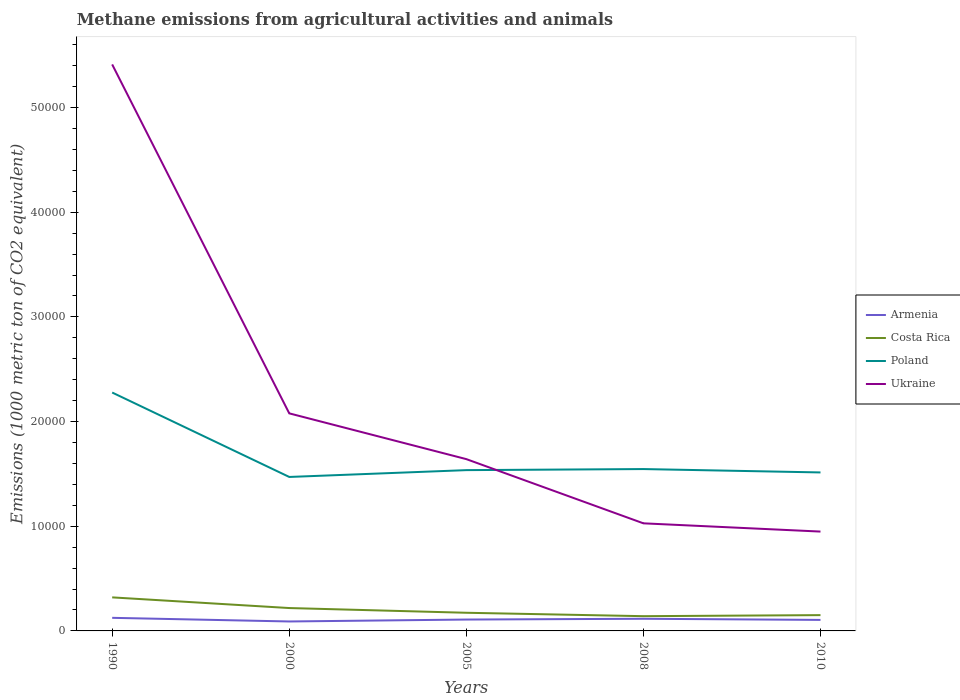Does the line corresponding to Ukraine intersect with the line corresponding to Armenia?
Offer a terse response. No. Across all years, what is the maximum amount of methane emitted in Costa Rica?
Provide a short and direct response. 1409.6. In which year was the amount of methane emitted in Armenia maximum?
Keep it short and to the point. 2000. What is the total amount of methane emitted in Ukraine in the graph?
Your response must be concise. 4.38e+04. What is the difference between the highest and the second highest amount of methane emitted in Costa Rica?
Make the answer very short. 1795. What is the difference between the highest and the lowest amount of methane emitted in Ukraine?
Offer a terse response. 1. How many lines are there?
Provide a short and direct response. 4. What is the difference between two consecutive major ticks on the Y-axis?
Offer a very short reply. 10000. Does the graph contain any zero values?
Give a very brief answer. No. Does the graph contain grids?
Provide a short and direct response. No. Where does the legend appear in the graph?
Ensure brevity in your answer.  Center right. How many legend labels are there?
Make the answer very short. 4. What is the title of the graph?
Give a very brief answer. Methane emissions from agricultural activities and animals. What is the label or title of the X-axis?
Your answer should be compact. Years. What is the label or title of the Y-axis?
Offer a very short reply. Emissions (1000 metric ton of CO2 equivalent). What is the Emissions (1000 metric ton of CO2 equivalent) in Armenia in 1990?
Provide a succinct answer. 1250.4. What is the Emissions (1000 metric ton of CO2 equivalent) of Costa Rica in 1990?
Your answer should be compact. 3204.6. What is the Emissions (1000 metric ton of CO2 equivalent) of Poland in 1990?
Offer a terse response. 2.28e+04. What is the Emissions (1000 metric ton of CO2 equivalent) in Ukraine in 1990?
Provide a short and direct response. 5.41e+04. What is the Emissions (1000 metric ton of CO2 equivalent) in Armenia in 2000?
Your response must be concise. 903.1. What is the Emissions (1000 metric ton of CO2 equivalent) in Costa Rica in 2000?
Offer a very short reply. 2184.6. What is the Emissions (1000 metric ton of CO2 equivalent) of Poland in 2000?
Ensure brevity in your answer.  1.47e+04. What is the Emissions (1000 metric ton of CO2 equivalent) in Ukraine in 2000?
Provide a succinct answer. 2.08e+04. What is the Emissions (1000 metric ton of CO2 equivalent) in Armenia in 2005?
Your answer should be very brief. 1086. What is the Emissions (1000 metric ton of CO2 equivalent) in Costa Rica in 2005?
Provide a short and direct response. 1735. What is the Emissions (1000 metric ton of CO2 equivalent) of Poland in 2005?
Give a very brief answer. 1.54e+04. What is the Emissions (1000 metric ton of CO2 equivalent) of Ukraine in 2005?
Offer a very short reply. 1.64e+04. What is the Emissions (1000 metric ton of CO2 equivalent) in Armenia in 2008?
Your answer should be very brief. 1161.5. What is the Emissions (1000 metric ton of CO2 equivalent) in Costa Rica in 2008?
Ensure brevity in your answer.  1409.6. What is the Emissions (1000 metric ton of CO2 equivalent) in Poland in 2008?
Keep it short and to the point. 1.55e+04. What is the Emissions (1000 metric ton of CO2 equivalent) in Ukraine in 2008?
Give a very brief answer. 1.03e+04. What is the Emissions (1000 metric ton of CO2 equivalent) of Armenia in 2010?
Your answer should be very brief. 1051.7. What is the Emissions (1000 metric ton of CO2 equivalent) in Costa Rica in 2010?
Provide a short and direct response. 1509.2. What is the Emissions (1000 metric ton of CO2 equivalent) in Poland in 2010?
Ensure brevity in your answer.  1.51e+04. What is the Emissions (1000 metric ton of CO2 equivalent) in Ukraine in 2010?
Offer a terse response. 9489.8. Across all years, what is the maximum Emissions (1000 metric ton of CO2 equivalent) in Armenia?
Ensure brevity in your answer.  1250.4. Across all years, what is the maximum Emissions (1000 metric ton of CO2 equivalent) in Costa Rica?
Your answer should be very brief. 3204.6. Across all years, what is the maximum Emissions (1000 metric ton of CO2 equivalent) of Poland?
Provide a succinct answer. 2.28e+04. Across all years, what is the maximum Emissions (1000 metric ton of CO2 equivalent) of Ukraine?
Make the answer very short. 5.41e+04. Across all years, what is the minimum Emissions (1000 metric ton of CO2 equivalent) of Armenia?
Make the answer very short. 903.1. Across all years, what is the minimum Emissions (1000 metric ton of CO2 equivalent) of Costa Rica?
Give a very brief answer. 1409.6. Across all years, what is the minimum Emissions (1000 metric ton of CO2 equivalent) in Poland?
Make the answer very short. 1.47e+04. Across all years, what is the minimum Emissions (1000 metric ton of CO2 equivalent) of Ukraine?
Your answer should be very brief. 9489.8. What is the total Emissions (1000 metric ton of CO2 equivalent) in Armenia in the graph?
Make the answer very short. 5452.7. What is the total Emissions (1000 metric ton of CO2 equivalent) of Costa Rica in the graph?
Offer a very short reply. 1.00e+04. What is the total Emissions (1000 metric ton of CO2 equivalent) in Poland in the graph?
Make the answer very short. 8.34e+04. What is the total Emissions (1000 metric ton of CO2 equivalent) in Ukraine in the graph?
Your answer should be very brief. 1.11e+05. What is the difference between the Emissions (1000 metric ton of CO2 equivalent) in Armenia in 1990 and that in 2000?
Your response must be concise. 347.3. What is the difference between the Emissions (1000 metric ton of CO2 equivalent) of Costa Rica in 1990 and that in 2000?
Your answer should be compact. 1020. What is the difference between the Emissions (1000 metric ton of CO2 equivalent) of Poland in 1990 and that in 2000?
Offer a very short reply. 8065. What is the difference between the Emissions (1000 metric ton of CO2 equivalent) in Ukraine in 1990 and that in 2000?
Provide a short and direct response. 3.33e+04. What is the difference between the Emissions (1000 metric ton of CO2 equivalent) in Armenia in 1990 and that in 2005?
Keep it short and to the point. 164.4. What is the difference between the Emissions (1000 metric ton of CO2 equivalent) in Costa Rica in 1990 and that in 2005?
Keep it short and to the point. 1469.6. What is the difference between the Emissions (1000 metric ton of CO2 equivalent) of Poland in 1990 and that in 2005?
Provide a short and direct response. 7413.7. What is the difference between the Emissions (1000 metric ton of CO2 equivalent) of Ukraine in 1990 and that in 2005?
Your answer should be very brief. 3.77e+04. What is the difference between the Emissions (1000 metric ton of CO2 equivalent) in Armenia in 1990 and that in 2008?
Keep it short and to the point. 88.9. What is the difference between the Emissions (1000 metric ton of CO2 equivalent) of Costa Rica in 1990 and that in 2008?
Provide a short and direct response. 1795. What is the difference between the Emissions (1000 metric ton of CO2 equivalent) of Poland in 1990 and that in 2008?
Provide a succinct answer. 7311.1. What is the difference between the Emissions (1000 metric ton of CO2 equivalent) in Ukraine in 1990 and that in 2008?
Ensure brevity in your answer.  4.38e+04. What is the difference between the Emissions (1000 metric ton of CO2 equivalent) in Armenia in 1990 and that in 2010?
Provide a succinct answer. 198.7. What is the difference between the Emissions (1000 metric ton of CO2 equivalent) in Costa Rica in 1990 and that in 2010?
Provide a short and direct response. 1695.4. What is the difference between the Emissions (1000 metric ton of CO2 equivalent) of Poland in 1990 and that in 2010?
Your answer should be very brief. 7634.1. What is the difference between the Emissions (1000 metric ton of CO2 equivalent) of Ukraine in 1990 and that in 2010?
Ensure brevity in your answer.  4.46e+04. What is the difference between the Emissions (1000 metric ton of CO2 equivalent) in Armenia in 2000 and that in 2005?
Make the answer very short. -182.9. What is the difference between the Emissions (1000 metric ton of CO2 equivalent) in Costa Rica in 2000 and that in 2005?
Your answer should be compact. 449.6. What is the difference between the Emissions (1000 metric ton of CO2 equivalent) in Poland in 2000 and that in 2005?
Your response must be concise. -651.3. What is the difference between the Emissions (1000 metric ton of CO2 equivalent) in Ukraine in 2000 and that in 2005?
Make the answer very short. 4372.1. What is the difference between the Emissions (1000 metric ton of CO2 equivalent) of Armenia in 2000 and that in 2008?
Offer a terse response. -258.4. What is the difference between the Emissions (1000 metric ton of CO2 equivalent) of Costa Rica in 2000 and that in 2008?
Keep it short and to the point. 775. What is the difference between the Emissions (1000 metric ton of CO2 equivalent) in Poland in 2000 and that in 2008?
Offer a very short reply. -753.9. What is the difference between the Emissions (1000 metric ton of CO2 equivalent) of Ukraine in 2000 and that in 2008?
Give a very brief answer. 1.05e+04. What is the difference between the Emissions (1000 metric ton of CO2 equivalent) of Armenia in 2000 and that in 2010?
Make the answer very short. -148.6. What is the difference between the Emissions (1000 metric ton of CO2 equivalent) of Costa Rica in 2000 and that in 2010?
Keep it short and to the point. 675.4. What is the difference between the Emissions (1000 metric ton of CO2 equivalent) in Poland in 2000 and that in 2010?
Offer a very short reply. -430.9. What is the difference between the Emissions (1000 metric ton of CO2 equivalent) in Ukraine in 2000 and that in 2010?
Give a very brief answer. 1.13e+04. What is the difference between the Emissions (1000 metric ton of CO2 equivalent) of Armenia in 2005 and that in 2008?
Your response must be concise. -75.5. What is the difference between the Emissions (1000 metric ton of CO2 equivalent) of Costa Rica in 2005 and that in 2008?
Make the answer very short. 325.4. What is the difference between the Emissions (1000 metric ton of CO2 equivalent) in Poland in 2005 and that in 2008?
Your response must be concise. -102.6. What is the difference between the Emissions (1000 metric ton of CO2 equivalent) in Ukraine in 2005 and that in 2008?
Keep it short and to the point. 6133.4. What is the difference between the Emissions (1000 metric ton of CO2 equivalent) of Armenia in 2005 and that in 2010?
Your answer should be very brief. 34.3. What is the difference between the Emissions (1000 metric ton of CO2 equivalent) of Costa Rica in 2005 and that in 2010?
Give a very brief answer. 225.8. What is the difference between the Emissions (1000 metric ton of CO2 equivalent) in Poland in 2005 and that in 2010?
Your response must be concise. 220.4. What is the difference between the Emissions (1000 metric ton of CO2 equivalent) in Ukraine in 2005 and that in 2010?
Ensure brevity in your answer.  6921.6. What is the difference between the Emissions (1000 metric ton of CO2 equivalent) in Armenia in 2008 and that in 2010?
Give a very brief answer. 109.8. What is the difference between the Emissions (1000 metric ton of CO2 equivalent) of Costa Rica in 2008 and that in 2010?
Your response must be concise. -99.6. What is the difference between the Emissions (1000 metric ton of CO2 equivalent) of Poland in 2008 and that in 2010?
Provide a short and direct response. 323. What is the difference between the Emissions (1000 metric ton of CO2 equivalent) of Ukraine in 2008 and that in 2010?
Offer a very short reply. 788.2. What is the difference between the Emissions (1000 metric ton of CO2 equivalent) in Armenia in 1990 and the Emissions (1000 metric ton of CO2 equivalent) in Costa Rica in 2000?
Offer a terse response. -934.2. What is the difference between the Emissions (1000 metric ton of CO2 equivalent) in Armenia in 1990 and the Emissions (1000 metric ton of CO2 equivalent) in Poland in 2000?
Offer a very short reply. -1.35e+04. What is the difference between the Emissions (1000 metric ton of CO2 equivalent) of Armenia in 1990 and the Emissions (1000 metric ton of CO2 equivalent) of Ukraine in 2000?
Make the answer very short. -1.95e+04. What is the difference between the Emissions (1000 metric ton of CO2 equivalent) of Costa Rica in 1990 and the Emissions (1000 metric ton of CO2 equivalent) of Poland in 2000?
Make the answer very short. -1.15e+04. What is the difference between the Emissions (1000 metric ton of CO2 equivalent) in Costa Rica in 1990 and the Emissions (1000 metric ton of CO2 equivalent) in Ukraine in 2000?
Keep it short and to the point. -1.76e+04. What is the difference between the Emissions (1000 metric ton of CO2 equivalent) of Poland in 1990 and the Emissions (1000 metric ton of CO2 equivalent) of Ukraine in 2000?
Your answer should be compact. 1990. What is the difference between the Emissions (1000 metric ton of CO2 equivalent) of Armenia in 1990 and the Emissions (1000 metric ton of CO2 equivalent) of Costa Rica in 2005?
Provide a short and direct response. -484.6. What is the difference between the Emissions (1000 metric ton of CO2 equivalent) in Armenia in 1990 and the Emissions (1000 metric ton of CO2 equivalent) in Poland in 2005?
Your response must be concise. -1.41e+04. What is the difference between the Emissions (1000 metric ton of CO2 equivalent) of Armenia in 1990 and the Emissions (1000 metric ton of CO2 equivalent) of Ukraine in 2005?
Provide a short and direct response. -1.52e+04. What is the difference between the Emissions (1000 metric ton of CO2 equivalent) in Costa Rica in 1990 and the Emissions (1000 metric ton of CO2 equivalent) in Poland in 2005?
Provide a short and direct response. -1.22e+04. What is the difference between the Emissions (1000 metric ton of CO2 equivalent) of Costa Rica in 1990 and the Emissions (1000 metric ton of CO2 equivalent) of Ukraine in 2005?
Your answer should be very brief. -1.32e+04. What is the difference between the Emissions (1000 metric ton of CO2 equivalent) of Poland in 1990 and the Emissions (1000 metric ton of CO2 equivalent) of Ukraine in 2005?
Give a very brief answer. 6362.1. What is the difference between the Emissions (1000 metric ton of CO2 equivalent) of Armenia in 1990 and the Emissions (1000 metric ton of CO2 equivalent) of Costa Rica in 2008?
Your answer should be very brief. -159.2. What is the difference between the Emissions (1000 metric ton of CO2 equivalent) in Armenia in 1990 and the Emissions (1000 metric ton of CO2 equivalent) in Poland in 2008?
Provide a succinct answer. -1.42e+04. What is the difference between the Emissions (1000 metric ton of CO2 equivalent) of Armenia in 1990 and the Emissions (1000 metric ton of CO2 equivalent) of Ukraine in 2008?
Your answer should be compact. -9027.6. What is the difference between the Emissions (1000 metric ton of CO2 equivalent) of Costa Rica in 1990 and the Emissions (1000 metric ton of CO2 equivalent) of Poland in 2008?
Offer a terse response. -1.23e+04. What is the difference between the Emissions (1000 metric ton of CO2 equivalent) of Costa Rica in 1990 and the Emissions (1000 metric ton of CO2 equivalent) of Ukraine in 2008?
Your answer should be very brief. -7073.4. What is the difference between the Emissions (1000 metric ton of CO2 equivalent) of Poland in 1990 and the Emissions (1000 metric ton of CO2 equivalent) of Ukraine in 2008?
Provide a short and direct response. 1.25e+04. What is the difference between the Emissions (1000 metric ton of CO2 equivalent) in Armenia in 1990 and the Emissions (1000 metric ton of CO2 equivalent) in Costa Rica in 2010?
Make the answer very short. -258.8. What is the difference between the Emissions (1000 metric ton of CO2 equivalent) in Armenia in 1990 and the Emissions (1000 metric ton of CO2 equivalent) in Poland in 2010?
Give a very brief answer. -1.39e+04. What is the difference between the Emissions (1000 metric ton of CO2 equivalent) of Armenia in 1990 and the Emissions (1000 metric ton of CO2 equivalent) of Ukraine in 2010?
Your response must be concise. -8239.4. What is the difference between the Emissions (1000 metric ton of CO2 equivalent) in Costa Rica in 1990 and the Emissions (1000 metric ton of CO2 equivalent) in Poland in 2010?
Your response must be concise. -1.19e+04. What is the difference between the Emissions (1000 metric ton of CO2 equivalent) of Costa Rica in 1990 and the Emissions (1000 metric ton of CO2 equivalent) of Ukraine in 2010?
Give a very brief answer. -6285.2. What is the difference between the Emissions (1000 metric ton of CO2 equivalent) in Poland in 1990 and the Emissions (1000 metric ton of CO2 equivalent) in Ukraine in 2010?
Ensure brevity in your answer.  1.33e+04. What is the difference between the Emissions (1000 metric ton of CO2 equivalent) of Armenia in 2000 and the Emissions (1000 metric ton of CO2 equivalent) of Costa Rica in 2005?
Offer a terse response. -831.9. What is the difference between the Emissions (1000 metric ton of CO2 equivalent) of Armenia in 2000 and the Emissions (1000 metric ton of CO2 equivalent) of Poland in 2005?
Provide a short and direct response. -1.45e+04. What is the difference between the Emissions (1000 metric ton of CO2 equivalent) in Armenia in 2000 and the Emissions (1000 metric ton of CO2 equivalent) in Ukraine in 2005?
Your answer should be compact. -1.55e+04. What is the difference between the Emissions (1000 metric ton of CO2 equivalent) of Costa Rica in 2000 and the Emissions (1000 metric ton of CO2 equivalent) of Poland in 2005?
Give a very brief answer. -1.32e+04. What is the difference between the Emissions (1000 metric ton of CO2 equivalent) in Costa Rica in 2000 and the Emissions (1000 metric ton of CO2 equivalent) in Ukraine in 2005?
Ensure brevity in your answer.  -1.42e+04. What is the difference between the Emissions (1000 metric ton of CO2 equivalent) in Poland in 2000 and the Emissions (1000 metric ton of CO2 equivalent) in Ukraine in 2005?
Give a very brief answer. -1702.9. What is the difference between the Emissions (1000 metric ton of CO2 equivalent) of Armenia in 2000 and the Emissions (1000 metric ton of CO2 equivalent) of Costa Rica in 2008?
Provide a short and direct response. -506.5. What is the difference between the Emissions (1000 metric ton of CO2 equivalent) in Armenia in 2000 and the Emissions (1000 metric ton of CO2 equivalent) in Poland in 2008?
Your answer should be compact. -1.46e+04. What is the difference between the Emissions (1000 metric ton of CO2 equivalent) of Armenia in 2000 and the Emissions (1000 metric ton of CO2 equivalent) of Ukraine in 2008?
Provide a short and direct response. -9374.9. What is the difference between the Emissions (1000 metric ton of CO2 equivalent) in Costa Rica in 2000 and the Emissions (1000 metric ton of CO2 equivalent) in Poland in 2008?
Provide a short and direct response. -1.33e+04. What is the difference between the Emissions (1000 metric ton of CO2 equivalent) of Costa Rica in 2000 and the Emissions (1000 metric ton of CO2 equivalent) of Ukraine in 2008?
Your response must be concise. -8093.4. What is the difference between the Emissions (1000 metric ton of CO2 equivalent) of Poland in 2000 and the Emissions (1000 metric ton of CO2 equivalent) of Ukraine in 2008?
Provide a short and direct response. 4430.5. What is the difference between the Emissions (1000 metric ton of CO2 equivalent) of Armenia in 2000 and the Emissions (1000 metric ton of CO2 equivalent) of Costa Rica in 2010?
Ensure brevity in your answer.  -606.1. What is the difference between the Emissions (1000 metric ton of CO2 equivalent) in Armenia in 2000 and the Emissions (1000 metric ton of CO2 equivalent) in Poland in 2010?
Your answer should be compact. -1.42e+04. What is the difference between the Emissions (1000 metric ton of CO2 equivalent) in Armenia in 2000 and the Emissions (1000 metric ton of CO2 equivalent) in Ukraine in 2010?
Your answer should be compact. -8586.7. What is the difference between the Emissions (1000 metric ton of CO2 equivalent) in Costa Rica in 2000 and the Emissions (1000 metric ton of CO2 equivalent) in Poland in 2010?
Your answer should be compact. -1.30e+04. What is the difference between the Emissions (1000 metric ton of CO2 equivalent) in Costa Rica in 2000 and the Emissions (1000 metric ton of CO2 equivalent) in Ukraine in 2010?
Give a very brief answer. -7305.2. What is the difference between the Emissions (1000 metric ton of CO2 equivalent) in Poland in 2000 and the Emissions (1000 metric ton of CO2 equivalent) in Ukraine in 2010?
Offer a very short reply. 5218.7. What is the difference between the Emissions (1000 metric ton of CO2 equivalent) of Armenia in 2005 and the Emissions (1000 metric ton of CO2 equivalent) of Costa Rica in 2008?
Your answer should be very brief. -323.6. What is the difference between the Emissions (1000 metric ton of CO2 equivalent) in Armenia in 2005 and the Emissions (1000 metric ton of CO2 equivalent) in Poland in 2008?
Keep it short and to the point. -1.44e+04. What is the difference between the Emissions (1000 metric ton of CO2 equivalent) in Armenia in 2005 and the Emissions (1000 metric ton of CO2 equivalent) in Ukraine in 2008?
Ensure brevity in your answer.  -9192. What is the difference between the Emissions (1000 metric ton of CO2 equivalent) of Costa Rica in 2005 and the Emissions (1000 metric ton of CO2 equivalent) of Poland in 2008?
Your response must be concise. -1.37e+04. What is the difference between the Emissions (1000 metric ton of CO2 equivalent) in Costa Rica in 2005 and the Emissions (1000 metric ton of CO2 equivalent) in Ukraine in 2008?
Your answer should be compact. -8543. What is the difference between the Emissions (1000 metric ton of CO2 equivalent) of Poland in 2005 and the Emissions (1000 metric ton of CO2 equivalent) of Ukraine in 2008?
Ensure brevity in your answer.  5081.8. What is the difference between the Emissions (1000 metric ton of CO2 equivalent) of Armenia in 2005 and the Emissions (1000 metric ton of CO2 equivalent) of Costa Rica in 2010?
Ensure brevity in your answer.  -423.2. What is the difference between the Emissions (1000 metric ton of CO2 equivalent) in Armenia in 2005 and the Emissions (1000 metric ton of CO2 equivalent) in Poland in 2010?
Offer a terse response. -1.41e+04. What is the difference between the Emissions (1000 metric ton of CO2 equivalent) in Armenia in 2005 and the Emissions (1000 metric ton of CO2 equivalent) in Ukraine in 2010?
Offer a terse response. -8403.8. What is the difference between the Emissions (1000 metric ton of CO2 equivalent) in Costa Rica in 2005 and the Emissions (1000 metric ton of CO2 equivalent) in Poland in 2010?
Provide a short and direct response. -1.34e+04. What is the difference between the Emissions (1000 metric ton of CO2 equivalent) in Costa Rica in 2005 and the Emissions (1000 metric ton of CO2 equivalent) in Ukraine in 2010?
Your answer should be very brief. -7754.8. What is the difference between the Emissions (1000 metric ton of CO2 equivalent) in Poland in 2005 and the Emissions (1000 metric ton of CO2 equivalent) in Ukraine in 2010?
Provide a short and direct response. 5870. What is the difference between the Emissions (1000 metric ton of CO2 equivalent) in Armenia in 2008 and the Emissions (1000 metric ton of CO2 equivalent) in Costa Rica in 2010?
Provide a succinct answer. -347.7. What is the difference between the Emissions (1000 metric ton of CO2 equivalent) in Armenia in 2008 and the Emissions (1000 metric ton of CO2 equivalent) in Poland in 2010?
Keep it short and to the point. -1.40e+04. What is the difference between the Emissions (1000 metric ton of CO2 equivalent) in Armenia in 2008 and the Emissions (1000 metric ton of CO2 equivalent) in Ukraine in 2010?
Make the answer very short. -8328.3. What is the difference between the Emissions (1000 metric ton of CO2 equivalent) of Costa Rica in 2008 and the Emissions (1000 metric ton of CO2 equivalent) of Poland in 2010?
Provide a short and direct response. -1.37e+04. What is the difference between the Emissions (1000 metric ton of CO2 equivalent) of Costa Rica in 2008 and the Emissions (1000 metric ton of CO2 equivalent) of Ukraine in 2010?
Keep it short and to the point. -8080.2. What is the difference between the Emissions (1000 metric ton of CO2 equivalent) of Poland in 2008 and the Emissions (1000 metric ton of CO2 equivalent) of Ukraine in 2010?
Provide a short and direct response. 5972.6. What is the average Emissions (1000 metric ton of CO2 equivalent) in Armenia per year?
Your response must be concise. 1090.54. What is the average Emissions (1000 metric ton of CO2 equivalent) in Costa Rica per year?
Give a very brief answer. 2008.6. What is the average Emissions (1000 metric ton of CO2 equivalent) of Poland per year?
Offer a terse response. 1.67e+04. What is the average Emissions (1000 metric ton of CO2 equivalent) of Ukraine per year?
Ensure brevity in your answer.  2.22e+04. In the year 1990, what is the difference between the Emissions (1000 metric ton of CO2 equivalent) in Armenia and Emissions (1000 metric ton of CO2 equivalent) in Costa Rica?
Offer a very short reply. -1954.2. In the year 1990, what is the difference between the Emissions (1000 metric ton of CO2 equivalent) of Armenia and Emissions (1000 metric ton of CO2 equivalent) of Poland?
Provide a succinct answer. -2.15e+04. In the year 1990, what is the difference between the Emissions (1000 metric ton of CO2 equivalent) of Armenia and Emissions (1000 metric ton of CO2 equivalent) of Ukraine?
Provide a succinct answer. -5.29e+04. In the year 1990, what is the difference between the Emissions (1000 metric ton of CO2 equivalent) in Costa Rica and Emissions (1000 metric ton of CO2 equivalent) in Poland?
Ensure brevity in your answer.  -1.96e+04. In the year 1990, what is the difference between the Emissions (1000 metric ton of CO2 equivalent) of Costa Rica and Emissions (1000 metric ton of CO2 equivalent) of Ukraine?
Provide a short and direct response. -5.09e+04. In the year 1990, what is the difference between the Emissions (1000 metric ton of CO2 equivalent) in Poland and Emissions (1000 metric ton of CO2 equivalent) in Ukraine?
Provide a succinct answer. -3.13e+04. In the year 2000, what is the difference between the Emissions (1000 metric ton of CO2 equivalent) of Armenia and Emissions (1000 metric ton of CO2 equivalent) of Costa Rica?
Ensure brevity in your answer.  -1281.5. In the year 2000, what is the difference between the Emissions (1000 metric ton of CO2 equivalent) in Armenia and Emissions (1000 metric ton of CO2 equivalent) in Poland?
Provide a short and direct response. -1.38e+04. In the year 2000, what is the difference between the Emissions (1000 metric ton of CO2 equivalent) of Armenia and Emissions (1000 metric ton of CO2 equivalent) of Ukraine?
Provide a succinct answer. -1.99e+04. In the year 2000, what is the difference between the Emissions (1000 metric ton of CO2 equivalent) in Costa Rica and Emissions (1000 metric ton of CO2 equivalent) in Poland?
Keep it short and to the point. -1.25e+04. In the year 2000, what is the difference between the Emissions (1000 metric ton of CO2 equivalent) of Costa Rica and Emissions (1000 metric ton of CO2 equivalent) of Ukraine?
Make the answer very short. -1.86e+04. In the year 2000, what is the difference between the Emissions (1000 metric ton of CO2 equivalent) of Poland and Emissions (1000 metric ton of CO2 equivalent) of Ukraine?
Keep it short and to the point. -6075. In the year 2005, what is the difference between the Emissions (1000 metric ton of CO2 equivalent) of Armenia and Emissions (1000 metric ton of CO2 equivalent) of Costa Rica?
Provide a short and direct response. -649. In the year 2005, what is the difference between the Emissions (1000 metric ton of CO2 equivalent) of Armenia and Emissions (1000 metric ton of CO2 equivalent) of Poland?
Your answer should be compact. -1.43e+04. In the year 2005, what is the difference between the Emissions (1000 metric ton of CO2 equivalent) of Armenia and Emissions (1000 metric ton of CO2 equivalent) of Ukraine?
Ensure brevity in your answer.  -1.53e+04. In the year 2005, what is the difference between the Emissions (1000 metric ton of CO2 equivalent) of Costa Rica and Emissions (1000 metric ton of CO2 equivalent) of Poland?
Ensure brevity in your answer.  -1.36e+04. In the year 2005, what is the difference between the Emissions (1000 metric ton of CO2 equivalent) in Costa Rica and Emissions (1000 metric ton of CO2 equivalent) in Ukraine?
Offer a very short reply. -1.47e+04. In the year 2005, what is the difference between the Emissions (1000 metric ton of CO2 equivalent) in Poland and Emissions (1000 metric ton of CO2 equivalent) in Ukraine?
Provide a short and direct response. -1051.6. In the year 2008, what is the difference between the Emissions (1000 metric ton of CO2 equivalent) of Armenia and Emissions (1000 metric ton of CO2 equivalent) of Costa Rica?
Provide a succinct answer. -248.1. In the year 2008, what is the difference between the Emissions (1000 metric ton of CO2 equivalent) of Armenia and Emissions (1000 metric ton of CO2 equivalent) of Poland?
Give a very brief answer. -1.43e+04. In the year 2008, what is the difference between the Emissions (1000 metric ton of CO2 equivalent) of Armenia and Emissions (1000 metric ton of CO2 equivalent) of Ukraine?
Provide a short and direct response. -9116.5. In the year 2008, what is the difference between the Emissions (1000 metric ton of CO2 equivalent) in Costa Rica and Emissions (1000 metric ton of CO2 equivalent) in Poland?
Ensure brevity in your answer.  -1.41e+04. In the year 2008, what is the difference between the Emissions (1000 metric ton of CO2 equivalent) of Costa Rica and Emissions (1000 metric ton of CO2 equivalent) of Ukraine?
Your answer should be very brief. -8868.4. In the year 2008, what is the difference between the Emissions (1000 metric ton of CO2 equivalent) of Poland and Emissions (1000 metric ton of CO2 equivalent) of Ukraine?
Your answer should be very brief. 5184.4. In the year 2010, what is the difference between the Emissions (1000 metric ton of CO2 equivalent) in Armenia and Emissions (1000 metric ton of CO2 equivalent) in Costa Rica?
Keep it short and to the point. -457.5. In the year 2010, what is the difference between the Emissions (1000 metric ton of CO2 equivalent) of Armenia and Emissions (1000 metric ton of CO2 equivalent) of Poland?
Your answer should be very brief. -1.41e+04. In the year 2010, what is the difference between the Emissions (1000 metric ton of CO2 equivalent) in Armenia and Emissions (1000 metric ton of CO2 equivalent) in Ukraine?
Offer a terse response. -8438.1. In the year 2010, what is the difference between the Emissions (1000 metric ton of CO2 equivalent) of Costa Rica and Emissions (1000 metric ton of CO2 equivalent) of Poland?
Provide a succinct answer. -1.36e+04. In the year 2010, what is the difference between the Emissions (1000 metric ton of CO2 equivalent) in Costa Rica and Emissions (1000 metric ton of CO2 equivalent) in Ukraine?
Offer a terse response. -7980.6. In the year 2010, what is the difference between the Emissions (1000 metric ton of CO2 equivalent) of Poland and Emissions (1000 metric ton of CO2 equivalent) of Ukraine?
Offer a very short reply. 5649.6. What is the ratio of the Emissions (1000 metric ton of CO2 equivalent) in Armenia in 1990 to that in 2000?
Offer a very short reply. 1.38. What is the ratio of the Emissions (1000 metric ton of CO2 equivalent) of Costa Rica in 1990 to that in 2000?
Your answer should be compact. 1.47. What is the ratio of the Emissions (1000 metric ton of CO2 equivalent) of Poland in 1990 to that in 2000?
Your answer should be very brief. 1.55. What is the ratio of the Emissions (1000 metric ton of CO2 equivalent) of Ukraine in 1990 to that in 2000?
Offer a terse response. 2.6. What is the ratio of the Emissions (1000 metric ton of CO2 equivalent) in Armenia in 1990 to that in 2005?
Keep it short and to the point. 1.15. What is the ratio of the Emissions (1000 metric ton of CO2 equivalent) of Costa Rica in 1990 to that in 2005?
Keep it short and to the point. 1.85. What is the ratio of the Emissions (1000 metric ton of CO2 equivalent) of Poland in 1990 to that in 2005?
Ensure brevity in your answer.  1.48. What is the ratio of the Emissions (1000 metric ton of CO2 equivalent) of Ukraine in 1990 to that in 2005?
Offer a terse response. 3.3. What is the ratio of the Emissions (1000 metric ton of CO2 equivalent) in Armenia in 1990 to that in 2008?
Provide a succinct answer. 1.08. What is the ratio of the Emissions (1000 metric ton of CO2 equivalent) in Costa Rica in 1990 to that in 2008?
Offer a terse response. 2.27. What is the ratio of the Emissions (1000 metric ton of CO2 equivalent) of Poland in 1990 to that in 2008?
Offer a very short reply. 1.47. What is the ratio of the Emissions (1000 metric ton of CO2 equivalent) in Ukraine in 1990 to that in 2008?
Your answer should be compact. 5.27. What is the ratio of the Emissions (1000 metric ton of CO2 equivalent) of Armenia in 1990 to that in 2010?
Provide a short and direct response. 1.19. What is the ratio of the Emissions (1000 metric ton of CO2 equivalent) in Costa Rica in 1990 to that in 2010?
Your answer should be compact. 2.12. What is the ratio of the Emissions (1000 metric ton of CO2 equivalent) of Poland in 1990 to that in 2010?
Give a very brief answer. 1.5. What is the ratio of the Emissions (1000 metric ton of CO2 equivalent) of Ukraine in 1990 to that in 2010?
Offer a terse response. 5.7. What is the ratio of the Emissions (1000 metric ton of CO2 equivalent) of Armenia in 2000 to that in 2005?
Give a very brief answer. 0.83. What is the ratio of the Emissions (1000 metric ton of CO2 equivalent) in Costa Rica in 2000 to that in 2005?
Provide a succinct answer. 1.26. What is the ratio of the Emissions (1000 metric ton of CO2 equivalent) of Poland in 2000 to that in 2005?
Your response must be concise. 0.96. What is the ratio of the Emissions (1000 metric ton of CO2 equivalent) of Ukraine in 2000 to that in 2005?
Offer a very short reply. 1.27. What is the ratio of the Emissions (1000 metric ton of CO2 equivalent) of Armenia in 2000 to that in 2008?
Give a very brief answer. 0.78. What is the ratio of the Emissions (1000 metric ton of CO2 equivalent) in Costa Rica in 2000 to that in 2008?
Provide a succinct answer. 1.55. What is the ratio of the Emissions (1000 metric ton of CO2 equivalent) of Poland in 2000 to that in 2008?
Provide a succinct answer. 0.95. What is the ratio of the Emissions (1000 metric ton of CO2 equivalent) of Ukraine in 2000 to that in 2008?
Your answer should be compact. 2.02. What is the ratio of the Emissions (1000 metric ton of CO2 equivalent) of Armenia in 2000 to that in 2010?
Provide a succinct answer. 0.86. What is the ratio of the Emissions (1000 metric ton of CO2 equivalent) in Costa Rica in 2000 to that in 2010?
Provide a succinct answer. 1.45. What is the ratio of the Emissions (1000 metric ton of CO2 equivalent) in Poland in 2000 to that in 2010?
Your answer should be very brief. 0.97. What is the ratio of the Emissions (1000 metric ton of CO2 equivalent) of Ukraine in 2000 to that in 2010?
Offer a very short reply. 2.19. What is the ratio of the Emissions (1000 metric ton of CO2 equivalent) of Armenia in 2005 to that in 2008?
Your answer should be very brief. 0.94. What is the ratio of the Emissions (1000 metric ton of CO2 equivalent) in Costa Rica in 2005 to that in 2008?
Provide a succinct answer. 1.23. What is the ratio of the Emissions (1000 metric ton of CO2 equivalent) in Ukraine in 2005 to that in 2008?
Ensure brevity in your answer.  1.6. What is the ratio of the Emissions (1000 metric ton of CO2 equivalent) in Armenia in 2005 to that in 2010?
Provide a succinct answer. 1.03. What is the ratio of the Emissions (1000 metric ton of CO2 equivalent) of Costa Rica in 2005 to that in 2010?
Ensure brevity in your answer.  1.15. What is the ratio of the Emissions (1000 metric ton of CO2 equivalent) in Poland in 2005 to that in 2010?
Make the answer very short. 1.01. What is the ratio of the Emissions (1000 metric ton of CO2 equivalent) in Ukraine in 2005 to that in 2010?
Provide a short and direct response. 1.73. What is the ratio of the Emissions (1000 metric ton of CO2 equivalent) of Armenia in 2008 to that in 2010?
Keep it short and to the point. 1.1. What is the ratio of the Emissions (1000 metric ton of CO2 equivalent) of Costa Rica in 2008 to that in 2010?
Your answer should be compact. 0.93. What is the ratio of the Emissions (1000 metric ton of CO2 equivalent) in Poland in 2008 to that in 2010?
Make the answer very short. 1.02. What is the ratio of the Emissions (1000 metric ton of CO2 equivalent) in Ukraine in 2008 to that in 2010?
Your answer should be very brief. 1.08. What is the difference between the highest and the second highest Emissions (1000 metric ton of CO2 equivalent) in Armenia?
Offer a very short reply. 88.9. What is the difference between the highest and the second highest Emissions (1000 metric ton of CO2 equivalent) of Costa Rica?
Make the answer very short. 1020. What is the difference between the highest and the second highest Emissions (1000 metric ton of CO2 equivalent) in Poland?
Offer a terse response. 7311.1. What is the difference between the highest and the second highest Emissions (1000 metric ton of CO2 equivalent) of Ukraine?
Provide a succinct answer. 3.33e+04. What is the difference between the highest and the lowest Emissions (1000 metric ton of CO2 equivalent) of Armenia?
Ensure brevity in your answer.  347.3. What is the difference between the highest and the lowest Emissions (1000 metric ton of CO2 equivalent) of Costa Rica?
Your answer should be very brief. 1795. What is the difference between the highest and the lowest Emissions (1000 metric ton of CO2 equivalent) of Poland?
Ensure brevity in your answer.  8065. What is the difference between the highest and the lowest Emissions (1000 metric ton of CO2 equivalent) in Ukraine?
Ensure brevity in your answer.  4.46e+04. 